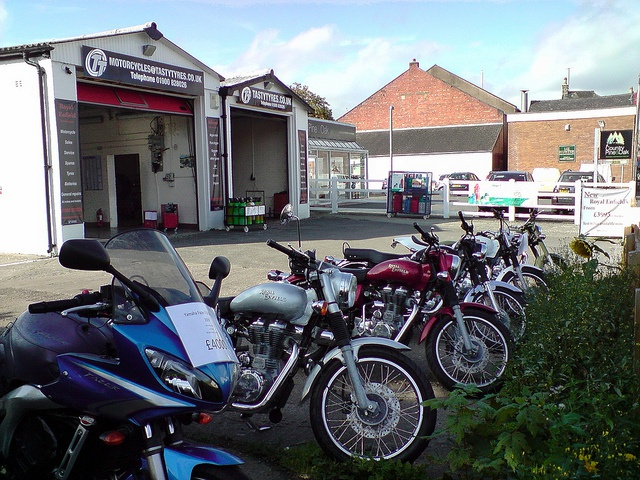Describe the objects in this image and their specific colors. I can see motorcycle in lightblue, black, navy, and gray tones, motorcycle in lightblue, black, gray, and darkgray tones, motorcycle in lightblue, black, gray, navy, and darkgray tones, motorcycle in lightblue, black, gray, darkgray, and navy tones, and motorcycle in lightblue, black, darkgray, gray, and lightgray tones in this image. 